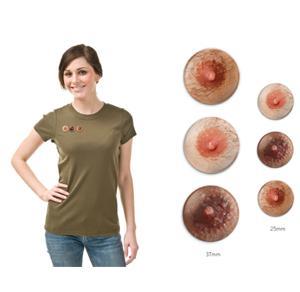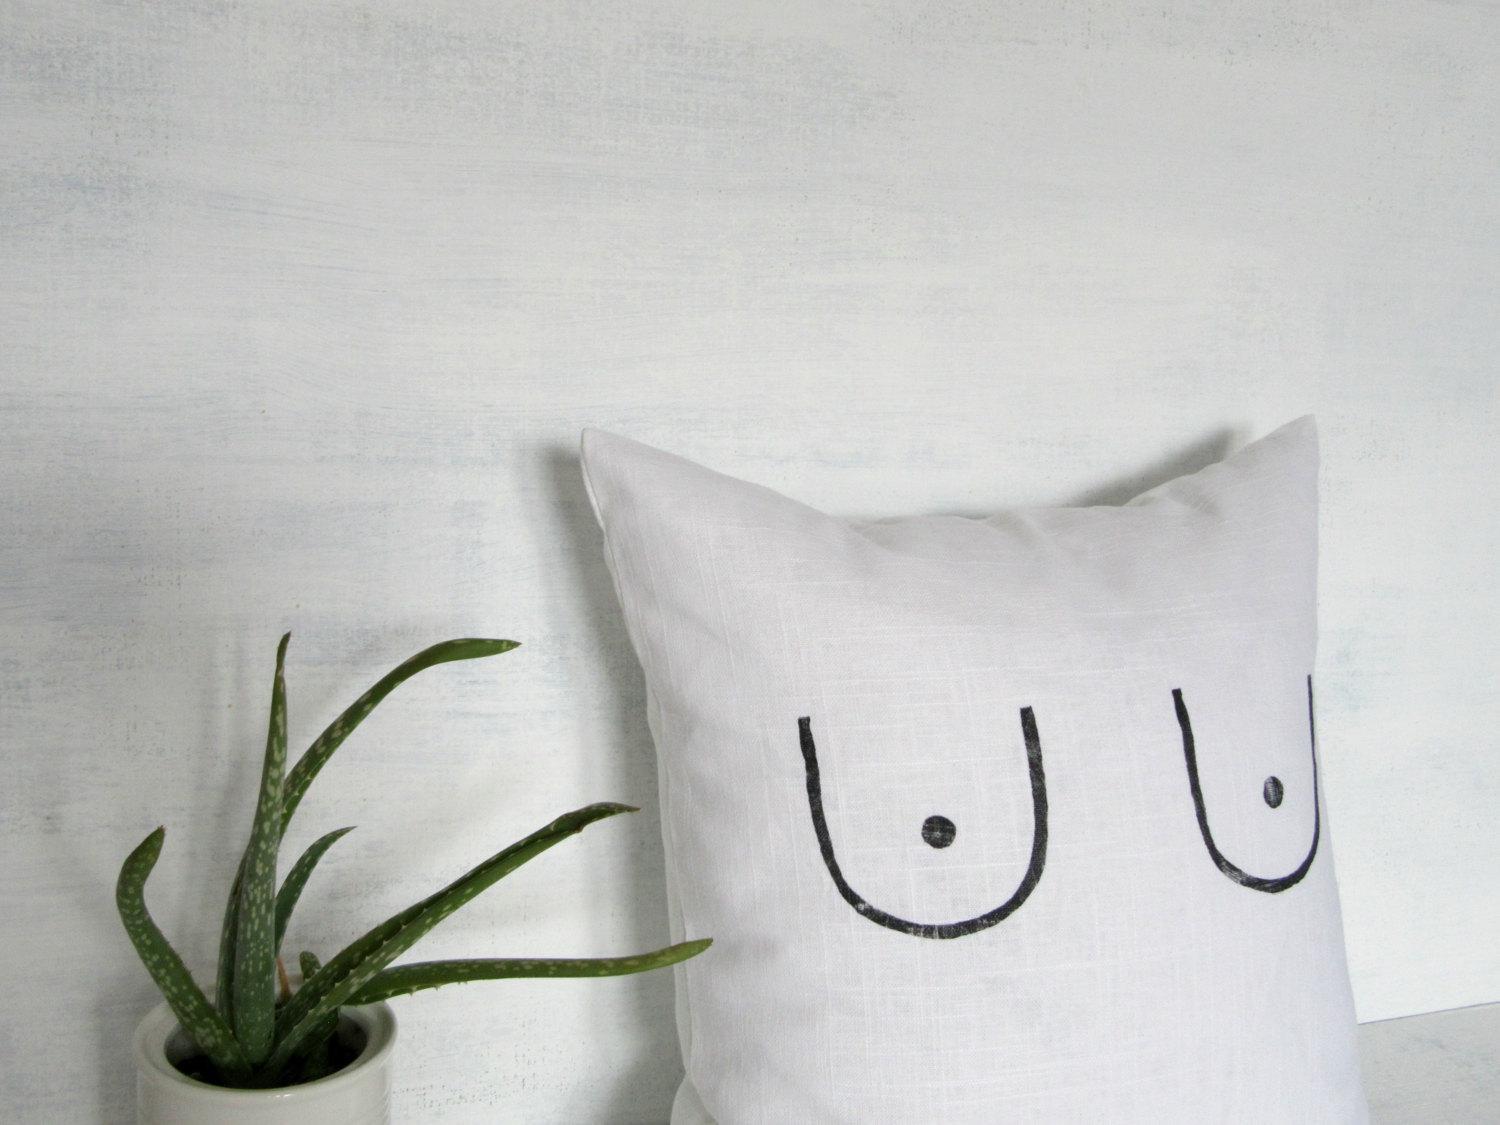The first image is the image on the left, the second image is the image on the right. Given the left and right images, does the statement "There is a single white pillow with a pair of breasts on them." hold true? Answer yes or no. Yes. 